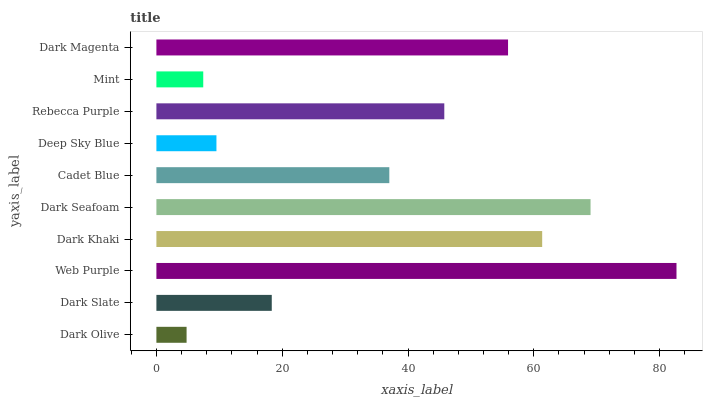Is Dark Olive the minimum?
Answer yes or no. Yes. Is Web Purple the maximum?
Answer yes or no. Yes. Is Dark Slate the minimum?
Answer yes or no. No. Is Dark Slate the maximum?
Answer yes or no. No. Is Dark Slate greater than Dark Olive?
Answer yes or no. Yes. Is Dark Olive less than Dark Slate?
Answer yes or no. Yes. Is Dark Olive greater than Dark Slate?
Answer yes or no. No. Is Dark Slate less than Dark Olive?
Answer yes or no. No. Is Rebecca Purple the high median?
Answer yes or no. Yes. Is Cadet Blue the low median?
Answer yes or no. Yes. Is Mint the high median?
Answer yes or no. No. Is Dark Magenta the low median?
Answer yes or no. No. 